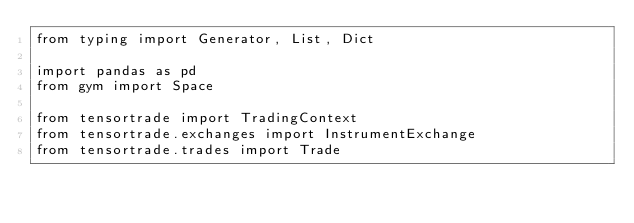<code> <loc_0><loc_0><loc_500><loc_500><_Python_>from typing import Generator, List, Dict

import pandas as pd
from gym import Space

from tensortrade import TradingContext
from tensortrade.exchanges import InstrumentExchange
from tensortrade.trades import Trade
</code> 